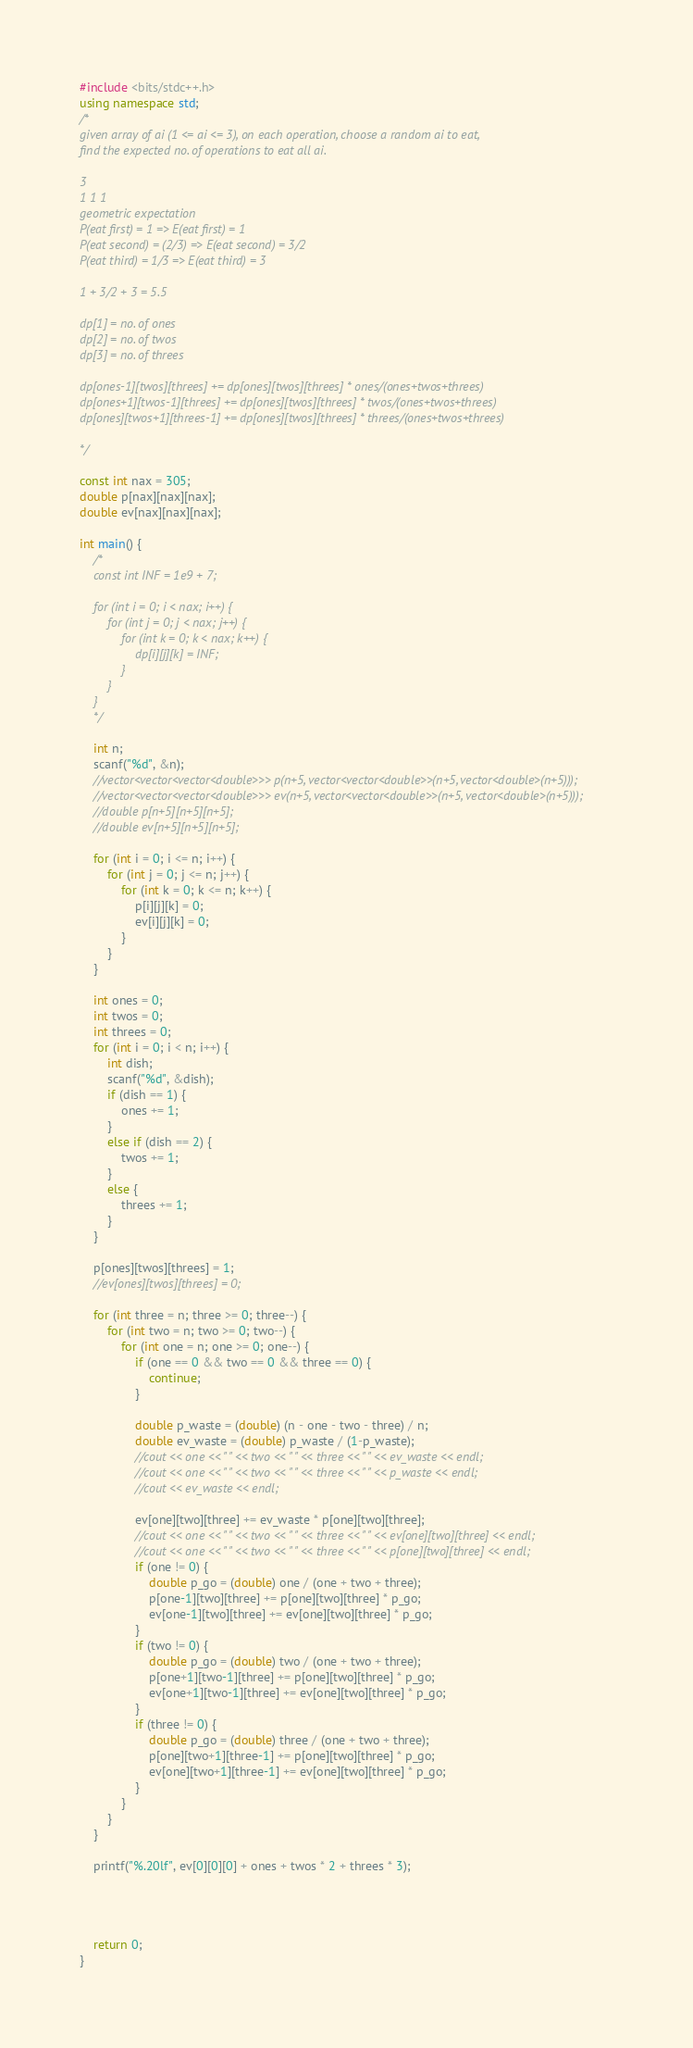<code> <loc_0><loc_0><loc_500><loc_500><_C++_>#include <bits/stdc++.h>
using namespace std;
/*
given array of ai (1 <= ai <= 3), on each operation, choose a random ai to eat, 
find the expected no. of operations to eat all ai.

3
1 1 1
geometric expectation
P(eat first) = 1 => E(eat first) = 1
P(eat second) = (2/3) => E(eat second) = 3/2 
P(eat third) = 1/3 => E(eat third) = 3 

1 + 3/2 + 3 = 5.5

dp[1] = no. of ones
dp[2] = no. of twos
dp[3] = no. of threes

dp[ones-1][twos][threes] += dp[ones][twos][threes] * ones/(ones+twos+threes)
dp[ones+1][twos-1][threes] += dp[ones][twos][threes] * twos/(ones+twos+threes)
dp[ones][twos+1][threes-1] += dp[ones][twos][threes] * threes/(ones+twos+threes)

*/

const int nax = 305;
double p[nax][nax][nax];
double ev[nax][nax][nax];

int main() {
    /*
    const int INF = 1e9 + 7;
    
    for (int i = 0; i < nax; i++) {
        for (int j = 0; j < nax; j++) {
            for (int k = 0; k < nax; k++) {
                dp[i][j][k] = INF;
            }
        }
    }
    */
    
    int n;
    scanf("%d", &n);
    //vector<vector<vector<double>>> p(n+5, vector<vector<double>>(n+5, vector<double>(n+5)));
    //vector<vector<vector<double>>> ev(n+5, vector<vector<double>>(n+5, vector<double>(n+5)));
    //double p[n+5][n+5][n+5];
    //double ev[n+5][n+5][n+5];
    
    for (int i = 0; i <= n; i++) {
        for (int j = 0; j <= n; j++) {
            for (int k = 0; k <= n; k++) {
                p[i][j][k] = 0;
                ev[i][j][k] = 0;
            }
        }
    }
    
    int ones = 0;
    int twos = 0;
    int threes = 0;
    for (int i = 0; i < n; i++) {
        int dish;
        scanf("%d", &dish);
        if (dish == 1) {
            ones += 1;
        }
        else if (dish == 2) {
            twos += 1;
        }
        else {
            threes += 1;
        }
    }
    
    p[ones][twos][threes] = 1;
    //ev[ones][twos][threes] = 0;
    
    for (int three = n; three >= 0; three--) {
        for (int two = n; two >= 0; two--) {
            for (int one = n; one >= 0; one--) {
                if (one == 0 && two == 0 && three == 0) {
                    continue;
                }
                
                double p_waste = (double) (n - one - two - three) / n;
                double ev_waste = (double) p_waste / (1-p_waste);
                //cout << one << " " << two << " " << three << " " << ev_waste << endl;
                //cout << one << " " << two << " " << three << " " << p_waste << endl;
                //cout << ev_waste << endl;
                
                ev[one][two][three] += ev_waste * p[one][two][three];
                //cout << one << " " << two << " " << three << " " << ev[one][two][three] << endl;
                //cout << one << " " << two << " " << three << " " << p[one][two][three] << endl;
                if (one != 0) {
                    double p_go = (double) one / (one + two + three);
                    p[one-1][two][three] += p[one][two][three] * p_go;
                    ev[one-1][two][three] += ev[one][two][three] * p_go;
                }
                if (two != 0) {
                    double p_go = (double) two / (one + two + three);
                    p[one+1][two-1][three] += p[one][two][three] * p_go;
                    ev[one+1][two-1][three] += ev[one][two][three] * p_go;
                }
                if (three != 0) {
                    double p_go = (double) three / (one + two + three);
                    p[one][two+1][three-1] += p[one][two][three] * p_go;    
                    ev[one][two+1][three-1] += ev[one][two][three] * p_go;    
                }
            }
        }
    }
    
	printf("%.20lf", ev[0][0][0] + ones + twos * 2 + threes * 3);
	
	
	
	
	return 0;
}</code> 